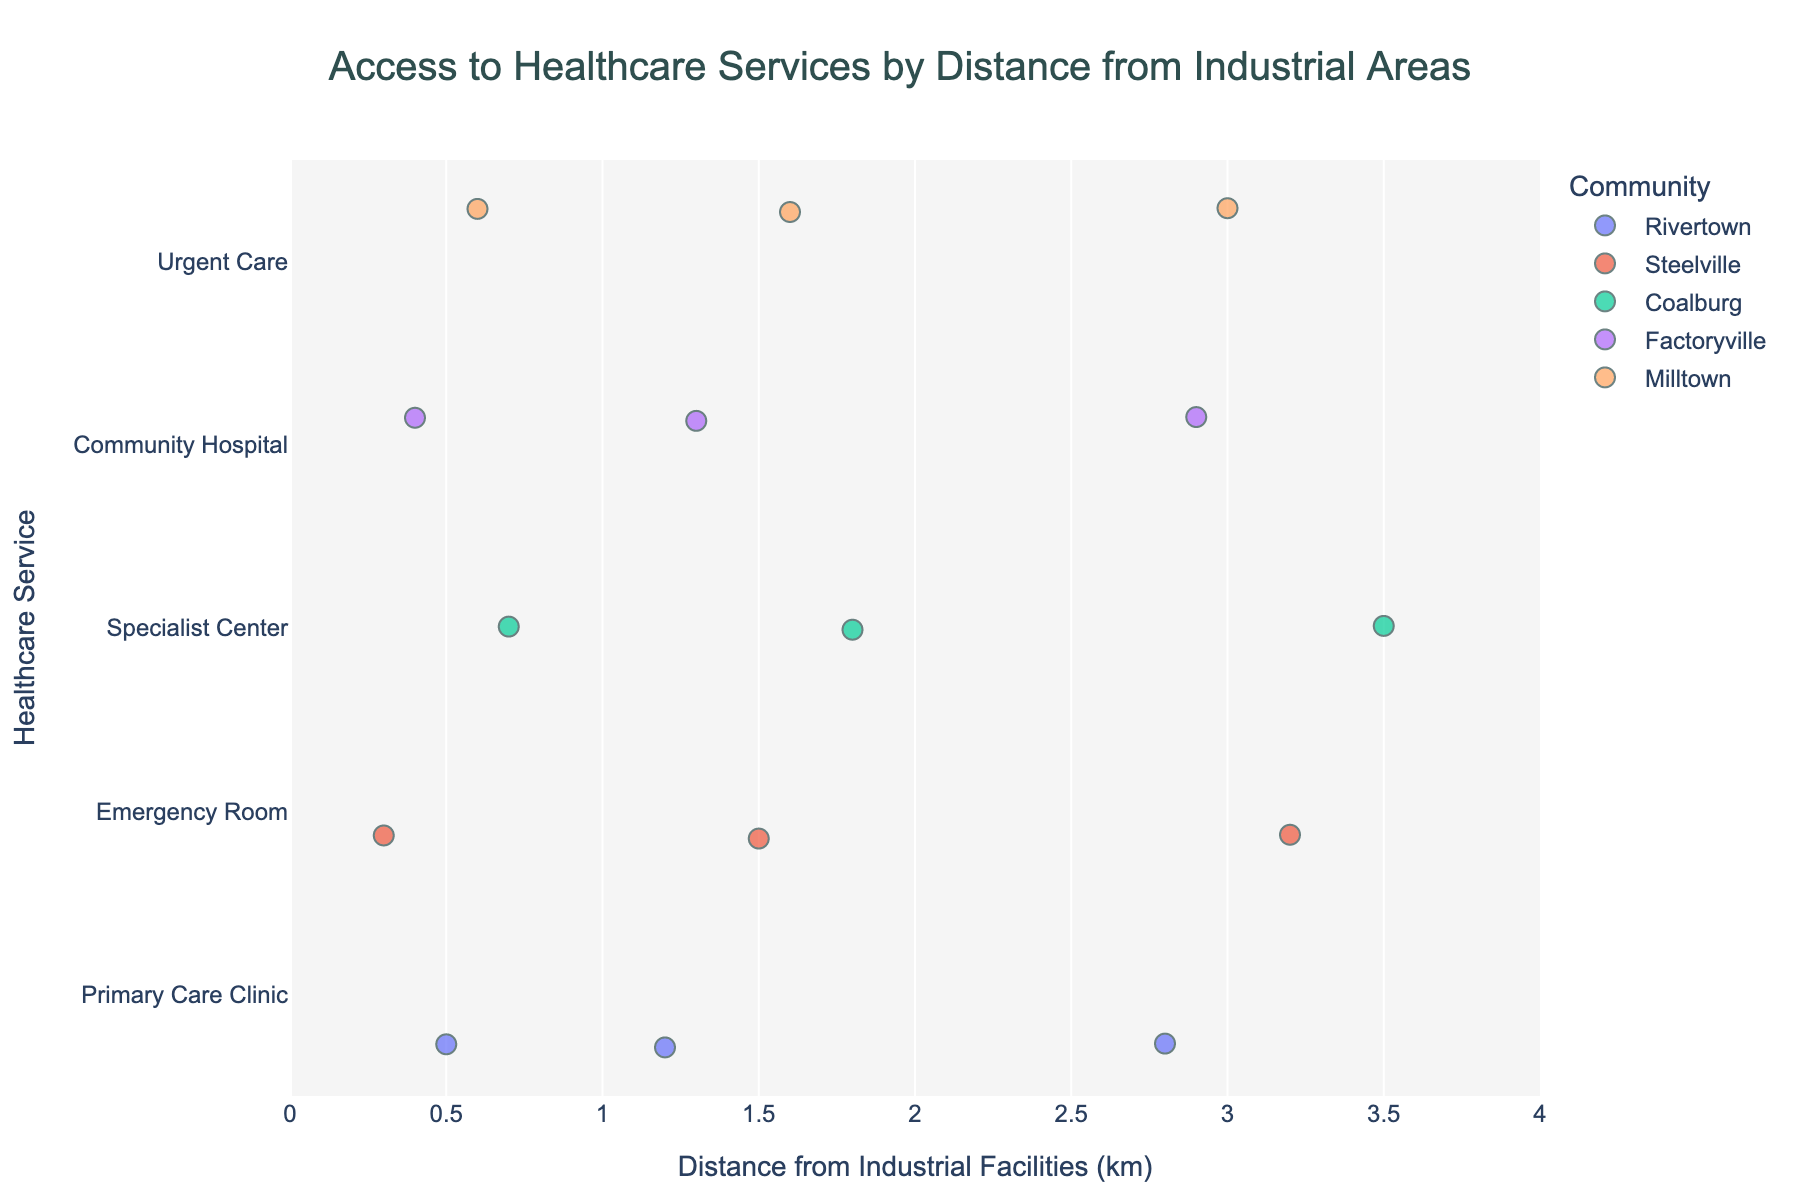How many healthcare services are shown in the figure? Count the different healthcare services mentioned along the y-axis of the plot: Primary Care Clinic, Emergency Room, Specialist Center, Community Hospital, and Urgent Care.
Answer: 5 What is the title of the plot? Read the title from the top of the figure, which summarizes the data’s primary focus.
Answer: Access to Healthcare Services by Distance from Industrial Areas Which community has an access score of 8? Look at the hover data for each community’s points and identify the point with an access score of 8.
Answer: Factoryville What is the maximum distance a healthcare service is from an industrial facility? Check the x-axis values and identify the largest value indicating the distance from industrial facilities.
Answer: 3.5 km Which healthcare service has the lowest access score in Milltown? Identify Milltown's data points in the figure and look at the hover data for the lowest access score.
Answer: Urgent Care What is the average access score for healthcare services in Rivertown? Identify all Rivertown’s access scores (3, 4, 6) and calculate the average: (3+4+6)/3 = 4.33.
Answer: 4.33 How does the access to the Emergency Room in Steelville compare to the Community Hospital in Factoryville at a distance of around 3 km? Compare the access scores for the Emergency Room at 3.2 km (score 7) and the Community Hospital at 2.9 km (score 8).
Answer: Community Hospital has slightly better access Which community has the widest range of access scores? Compare the range (difference between highest and lowest score) for each community: Rivertown (6-3=3), Steelville (7-2=5), Coalburg (6-2=4), Factoryville (8-3=5), Milltown (7-2=5). Steelville, Factoryville, and Milltown all have the widest range.
Answer: Steelville, Factoryville, and Milltown Is there a noticeable trend between distance from industrial facilities and access scores for specialist centers in Coalburg? Look for a pattern in the access scores for Specialist Center across different distances in Coalburg: 0.7 km (score 2), 1.8 km (score 4), 3.5 km (score 6). Notice that the access score increases with distance.
Answer: Yes, access increases with distance Which healthcare service in Rivertown shows the highest access score? Identify the highest access score for Rivertown across the Primary Care Clinic data points, which is 6.
Answer: Primary Care Clinic 